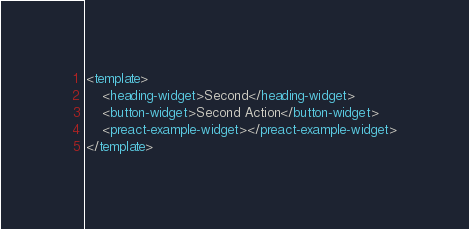Convert code to text. <code><loc_0><loc_0><loc_500><loc_500><_HTML_><template>
	<heading-widget>Second</heading-widget>
	<button-widget>Second Action</button-widget>
	<preact-example-widget></preact-example-widget>
</template></code> 